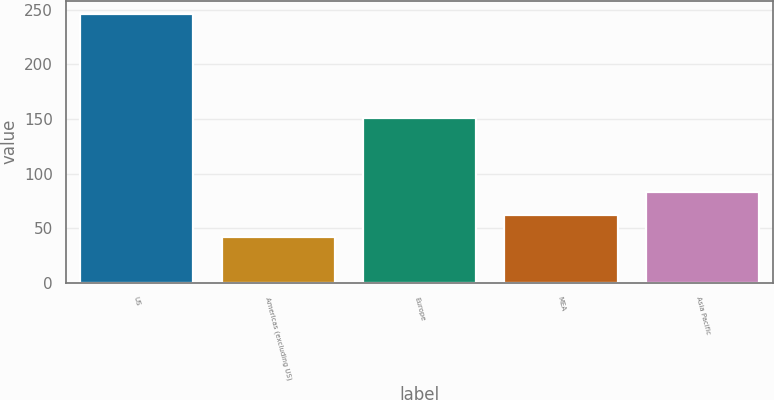Convert chart. <chart><loc_0><loc_0><loc_500><loc_500><bar_chart><fcel>US<fcel>Americas (excluding US)<fcel>Europe<fcel>MEA<fcel>Asia Pacific<nl><fcel>246<fcel>42<fcel>151<fcel>62.4<fcel>82.8<nl></chart> 